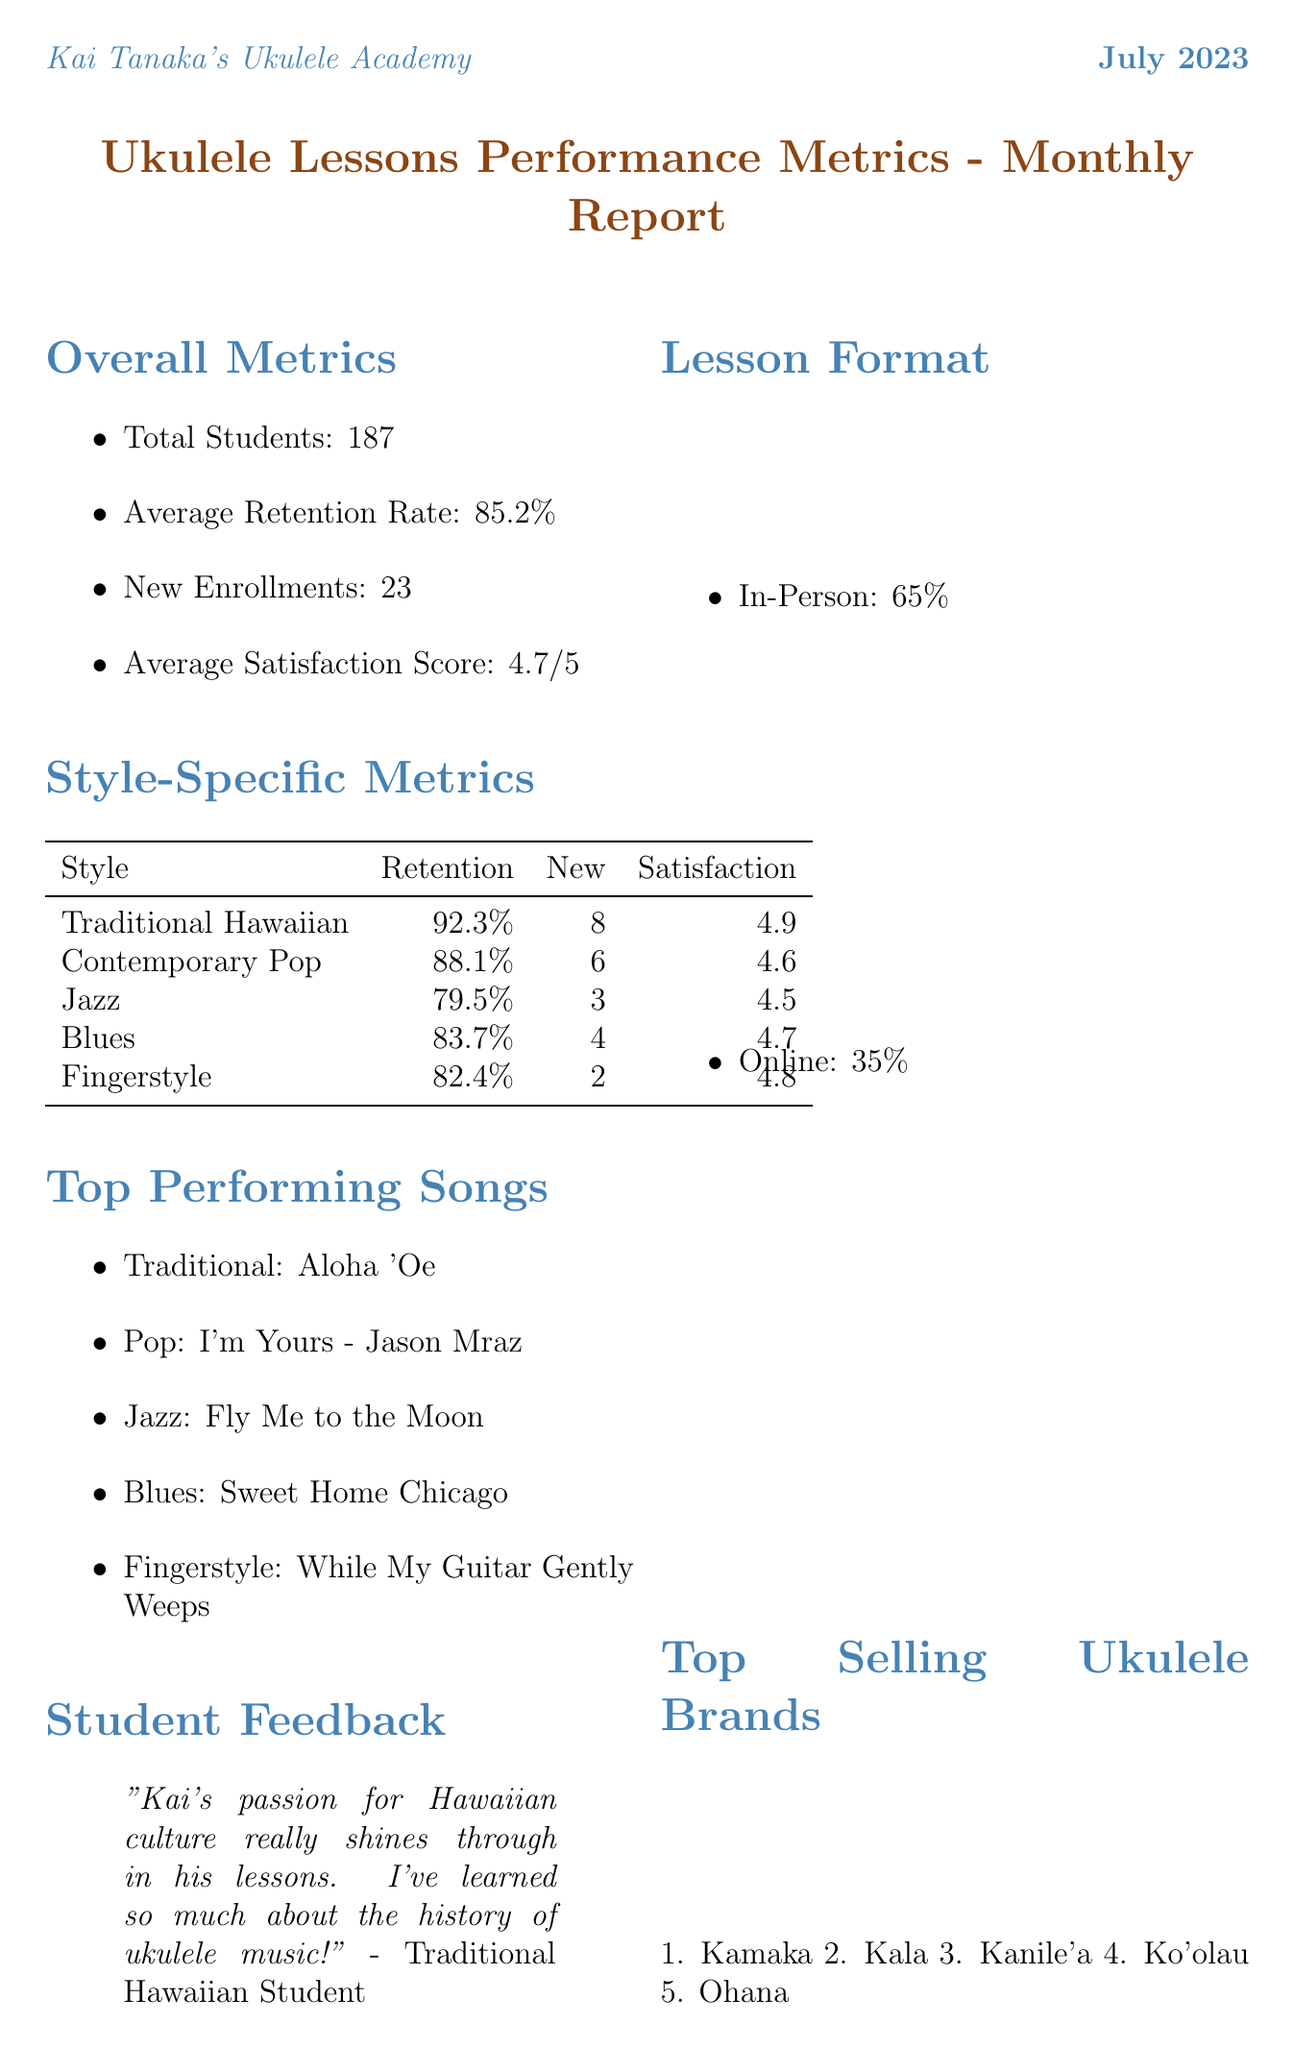What is the reporting period of the dashboard? The reporting period is specified at the top of the document, indicating the time frame for the reported metrics.
Answer: July 2023 Who is the instructor name mentioned in the report? The instructor name is prominently displayed in the document and identifies the person responsible for the ukulele lessons.
Answer: Kai Tanaka What is the total number of students? The total number of students is provided in the overall metrics section of the report.
Answer: 187 What is the average retention rate? The average retention rate is clearly indicated in the overall metrics section, representing student retention success.
Answer: 85.2% Which ukulele style has the highest retention rate? By examining the style-specific metrics, the retention rates can be compared to determine which style retains students best.
Answer: Traditional Hawaiian How many new enrollments were there in the Contemporary Pop style? The number of new enrollments for each style is detailed in the style-specific metrics, allowing for a direct comparison across styles.
Answer: 6 What is the average satisfaction score across all students? The average satisfaction score is found in the overall metrics section, summarizing student happiness with the lessons.
Answer: 4.7 What is the top-performing song in the Jazz style? The top-performing songs for each style are listed, allowing for identification of the most popular choices in Jazz lessons.
Answer: Fly Me to the Moon What percentage of lessons were in-person? The lesson format breakdown indicates the proportion of in-person versus online lessons, presenting a clear metric.
Answer: 65% 